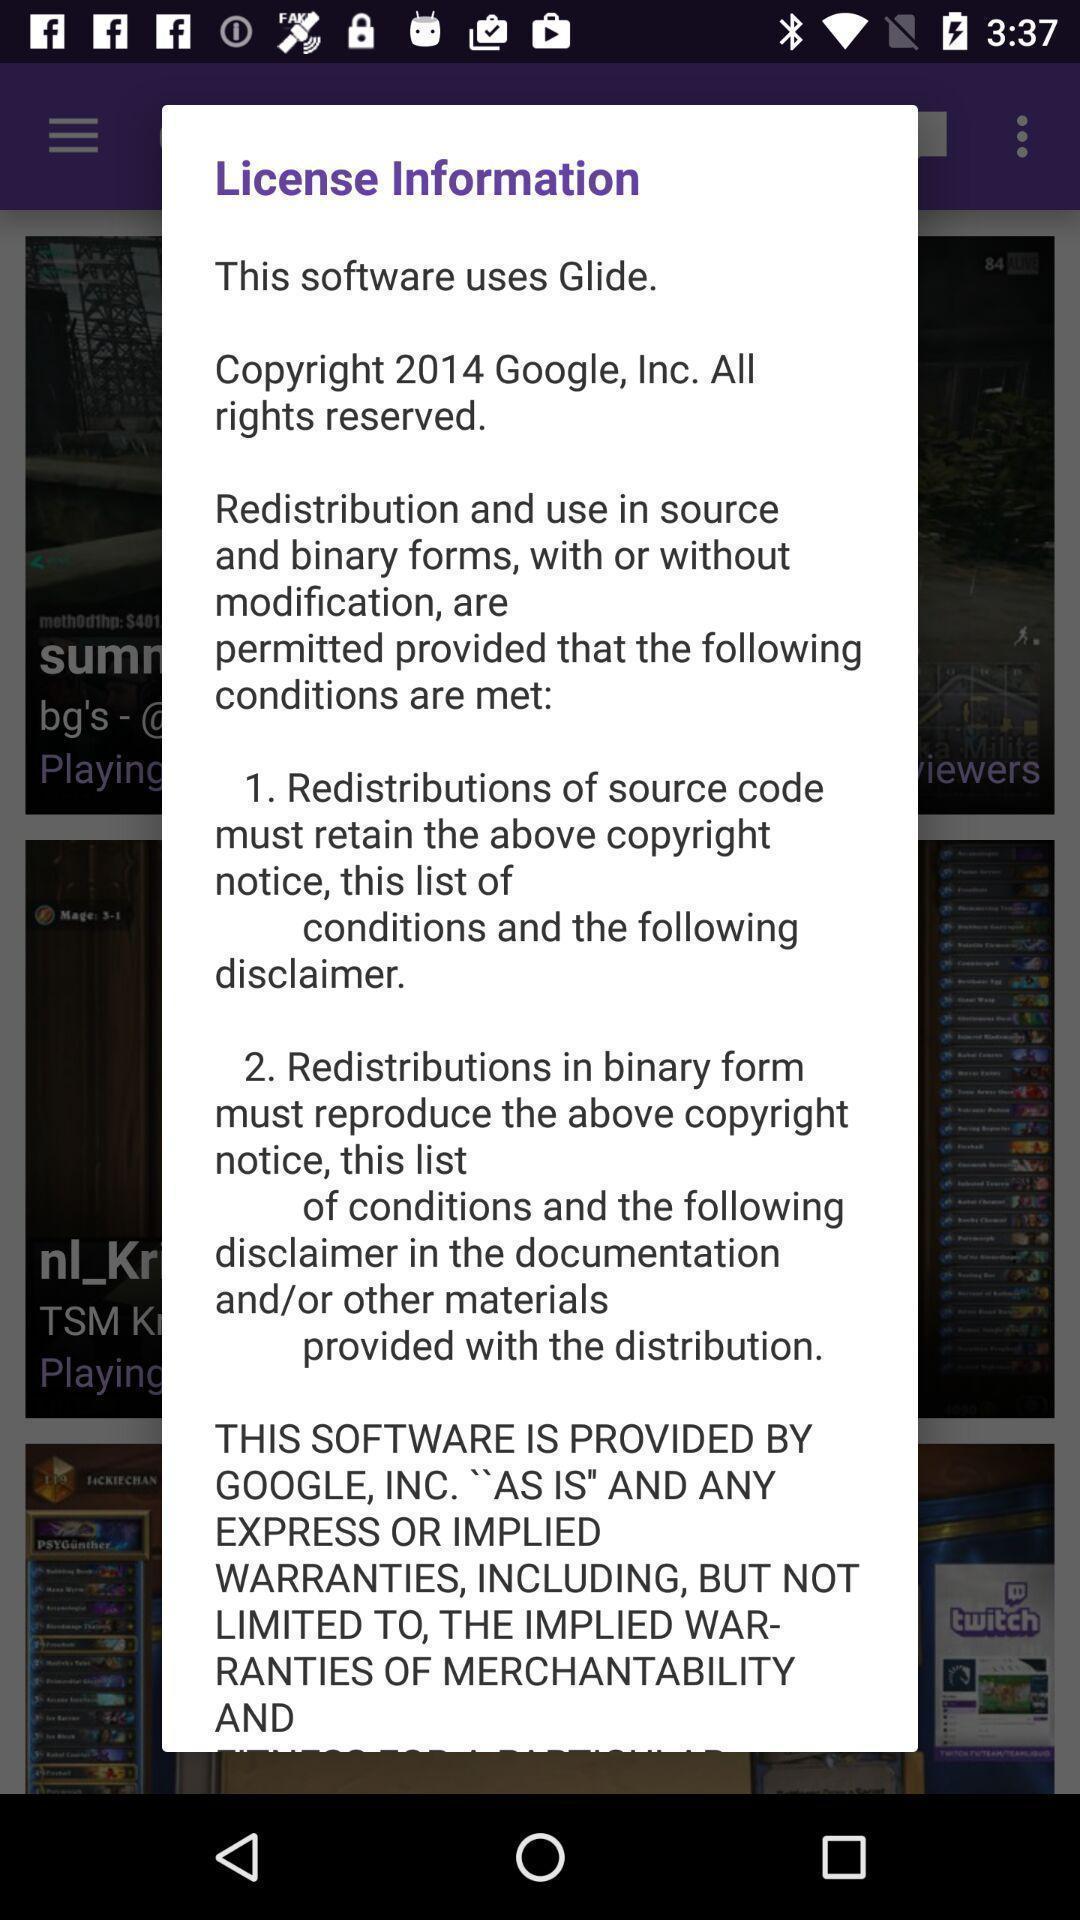Please provide a description for this image. Pop-up is showing about license information. 